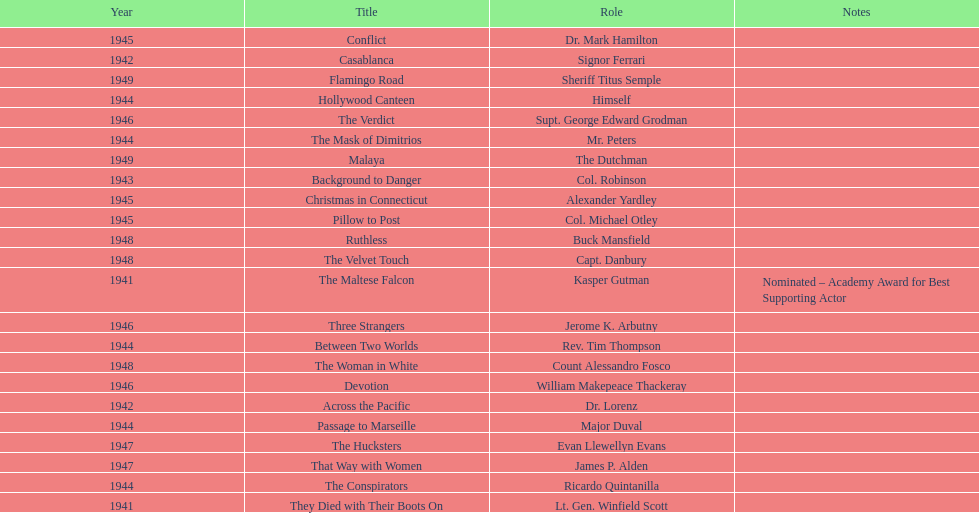How long did sydney greenstreet's acting career last? 9 years. 